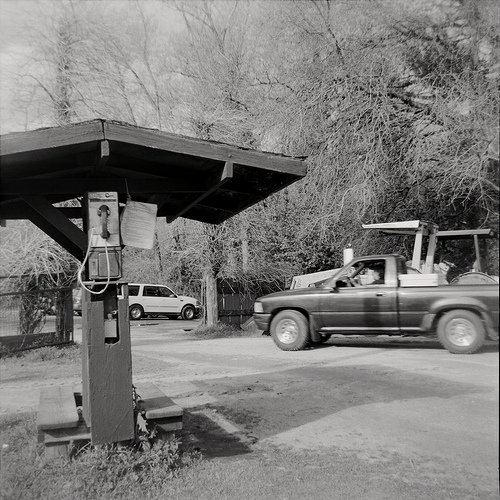What natural elements are visible in the image, and how do they interact with the man-made structures? The image features several natural elements, particularly the trees in the background, which create a canopy over the scene. These trees contribute to a rustic and serene atmosphere. The man-made structures, such as the wooden awning, benches, and the pay phone, seem integrated into this natural environment, emphasizing a harmonious coexistence between nature and human activity. Give a detailed description of the atmosphere and mood conveyed by the black-and-white format of the image. The black-and-white format of the image lends it a timeless, nostalgic quality, evoking memories of a simpler time. This monochromatic scheme enhances the focus on textures and contrasts, drawing attention to the weathered wood of the awning and the smooth metal of the pay phone. The interplay of light and shadow creates a sense of quietness and contemplation, fostering an atmosphere of calm and introspection. The absence of color encourages viewers to imagine the vibrancy and stories behind the scene, inviting a deeper emotional connection to the depicted moment. What role do you think the pay phone plays in the lives of the people in this community? The pay phone likely serves as a crucial communication tool for the community, especially in an era before the widespread use of mobile phones. It might be a central point where people can make calls when needed, keeping them connected to friends, family, and emergency services. Its placement under the wooden awning suggests it is also a spot where people might briefly gather, perhaps while waiting for their turn to use the phone or seeking shelter from the weather. This functional role gives the pay phone a significant presence in the community’s daily life. Imagine that the wooden awning could speak. What stories might it share about the world around it? If the wooden awning could speak, it might share countless stories of the people who have come and gone over the years. It could recount the laughter and conversations that have taken place beneath its shelter, the worried expressions of individuals making urgent calls, and the quiet moments of reprieve from the weather. It might tell tales of children playing nearby, adults discussing recent events, and the comforting routine of daily life in the community. Perhaps it’s seen generations grow up and witnessed changes in the landscape, yet remains a steadfast part of the local scenery, a silent witness to all the little dramas and joys of the neighborhood. 